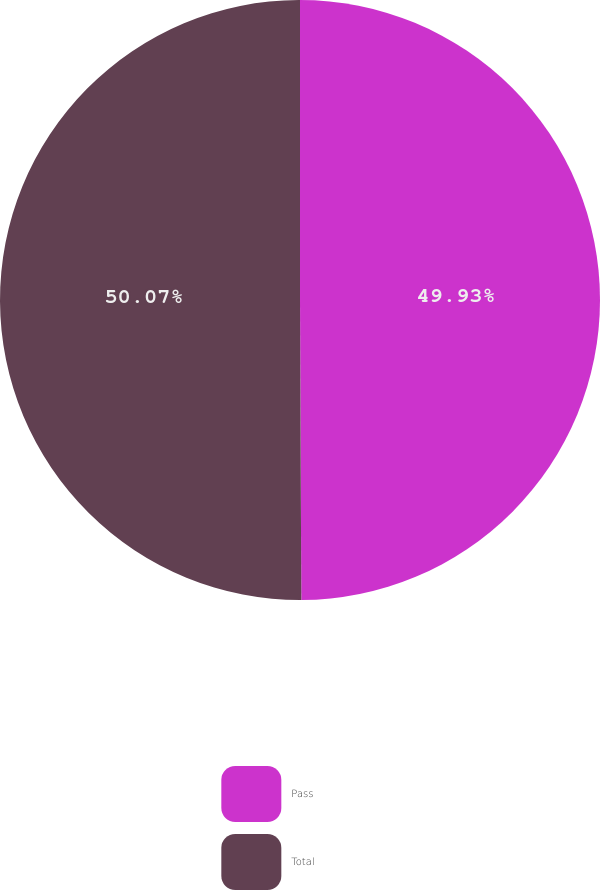<chart> <loc_0><loc_0><loc_500><loc_500><pie_chart><fcel>Pass<fcel>Total<nl><fcel>49.93%<fcel>50.07%<nl></chart> 